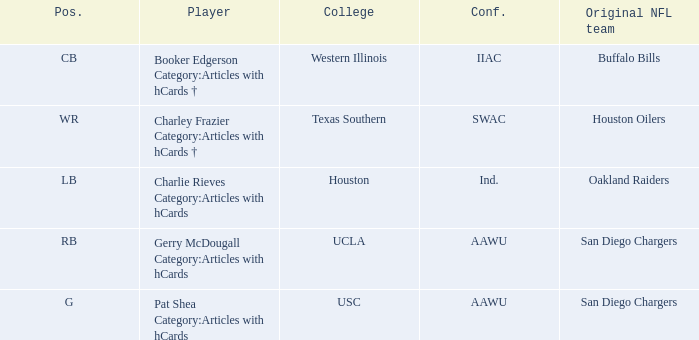What player's original team are the Buffalo Bills? Booker Edgerson Category:Articles with hCards †. 